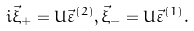<formula> <loc_0><loc_0><loc_500><loc_500>i \vec { \xi } _ { + } = U { \vec { \varepsilon } } ^ { ( 2 ) } , \vec { \xi } _ { - } = U { \vec { \varepsilon } } ^ { ( 1 ) } .</formula> 